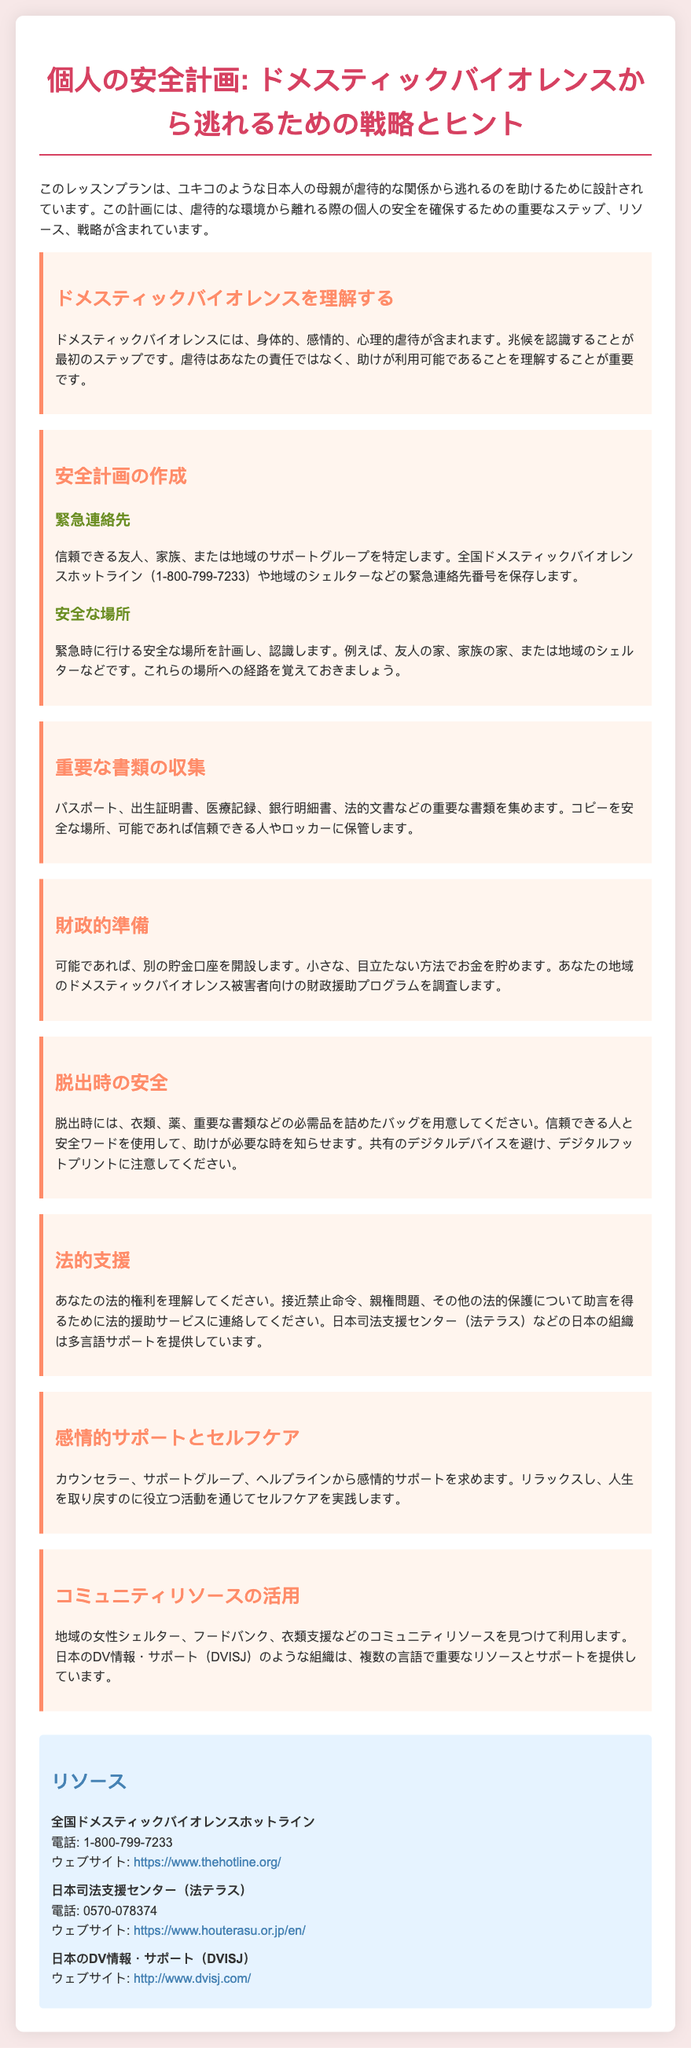What is the title of the lesson plan? The title is stated at the beginning of the document, which outlines the theme of personal safety planning.
Answer: 個人の安全計画: ドメスティックバイオレンスから逃れるための戦略とヒント What is the emergency contact number provided? The national domestic violence hotline number is found in the resource section of the document.
Answer: 1-800-799-7233 What is one resource for legal support mentioned? The document lists various resources, including one specific to legal support in Japan.
Answer: 日本司法支援センター（法テラス） What should be packed for escape? This is detailed under the "脱出時の安全" section, which highlights necessary items for a quick escape.
Answer: 衣類、薬、重要な書類 What is a recommended financial preparation? The lesson plan suggests opening a separate savings account for financial safety.
Answer: 別の貯金口座を開設します Why is it important to recognize the signs of domestic violence? This importance is emphasized in the section about understanding domestic violence.
Answer: 最初のステップ What type of emotional support is encouraged? The document advises seeking out specific types of support for emotional wellbeing during a crisis.
Answer: カウンセラー、サポートグループ、ヘルプライン What organization provides multilingual support? There are organizations mentioned that assist victims of domestic violence with support in multiple languages.
Answer: 日本のDV情報・サポート（DVISJ） 